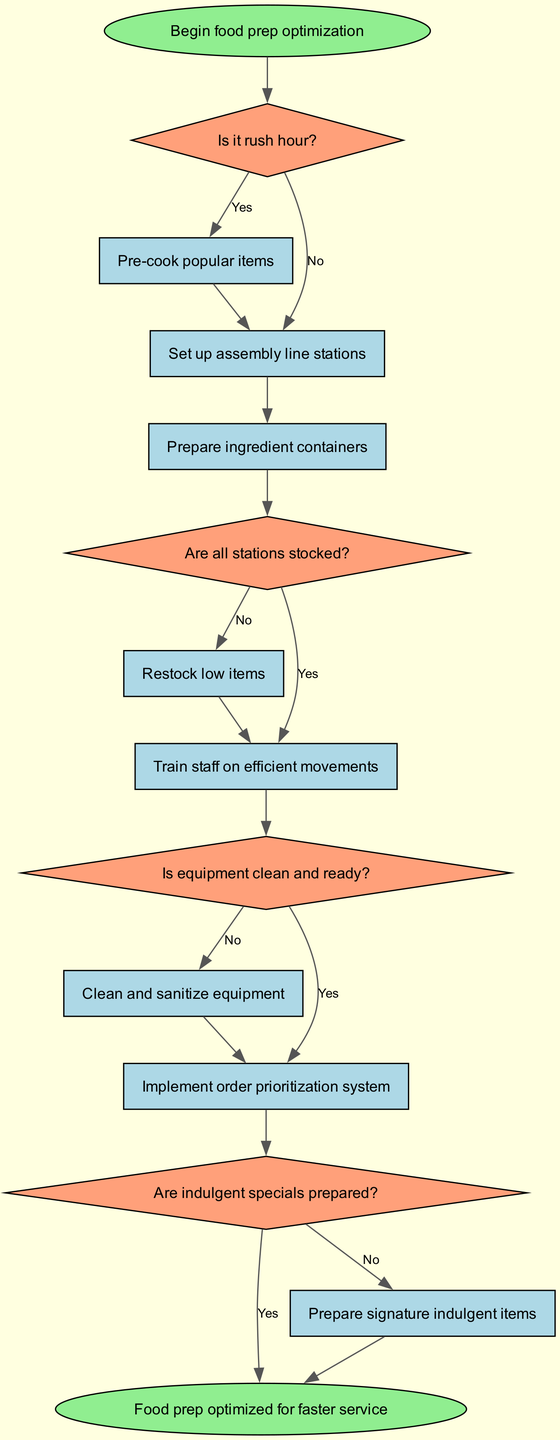What is the first decision in the flowchart? The flowchart begins with the node labeled "Is it rush hour?" as the first decision point that dictates the subsequent actions taken.
Answer: Is it rush hour? How many process nodes are in the diagram? By counting the nodes labeled as processes, there are a total of six process nodes in the flowchart, indicating various actions to be performed.
Answer: 6 What action follows the decision “Are all stations stocked?” if the answer is yes? If the answer to "Are all stations stocked?" is yes, the next action is to "Train staff on efficient movements," which is taken immediately following this decision.
Answer: Train staff on efficient movements What kind of item is prepared if indulgent specials are not ready? If the decision "Are indulgent specials prepared?" results in a "No," then the process that follows is to "Prepare signature indulgent items," indicating that these items are prioritized in the workflow.
Answer: Prepare signature indulgent items How many total edges connect process nodes in the flowchart? By analyzing the connections between process nodes in the diagram, it can be determined that there are five edges that specifically connect various process nodes, illustrating the flow of actions.
Answer: 5 If it is not rush hour, which action is taken after the assembly line stations are set up? After the assembly line stations are set up (in the case of not being rush hour), the next action is to "Prepare ingredient containers," indicating the workflow steps following this scenario.
Answer: Prepare ingredient containers What happens if the equipment is not clean and ready? If the equipment is not clean and ready, the flowchart dictates that the action "Clean and sanitize equipment" will take place before proceeding to the next decision.
Answer: Clean and sanitize equipment Are there any decisions before the equipment cleanliness check? Yes, there are two decisions before reaching the equipment cleanliness check: the first is "Is it rush hour?" and the second is "Are all stations stocked?" both occurring sequentially prior to this decision.
Answer: Yes 